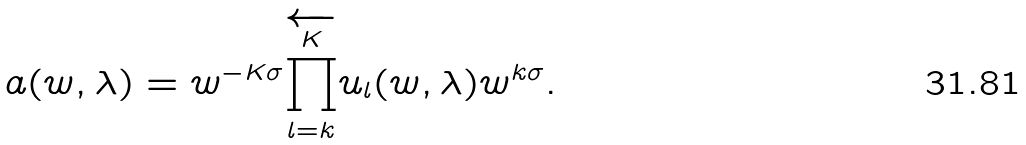<formula> <loc_0><loc_0><loc_500><loc_500>a ( w , \lambda ) = w ^ { - K \sigma } \overleftarrow { \prod _ { l = k } ^ { K } } u _ { l } ( w , \lambda ) w ^ { k \sigma } .</formula> 